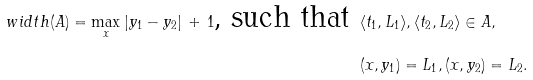Convert formula to latex. <formula><loc_0><loc_0><loc_500><loc_500>w i d t h ( A ) = \max _ { x } | y _ { 1 } - y _ { 2 } | \, + \, 1 \text {, such that } & \langle t _ { 1 } , L _ { 1 } \rangle , \langle t _ { 2 } , L _ { 2 } \rangle \in A , \\ & ( x , y _ { 1 } ) = L _ { 1 } , ( x , y _ { 2 } ) = L _ { 2 } .</formula> 